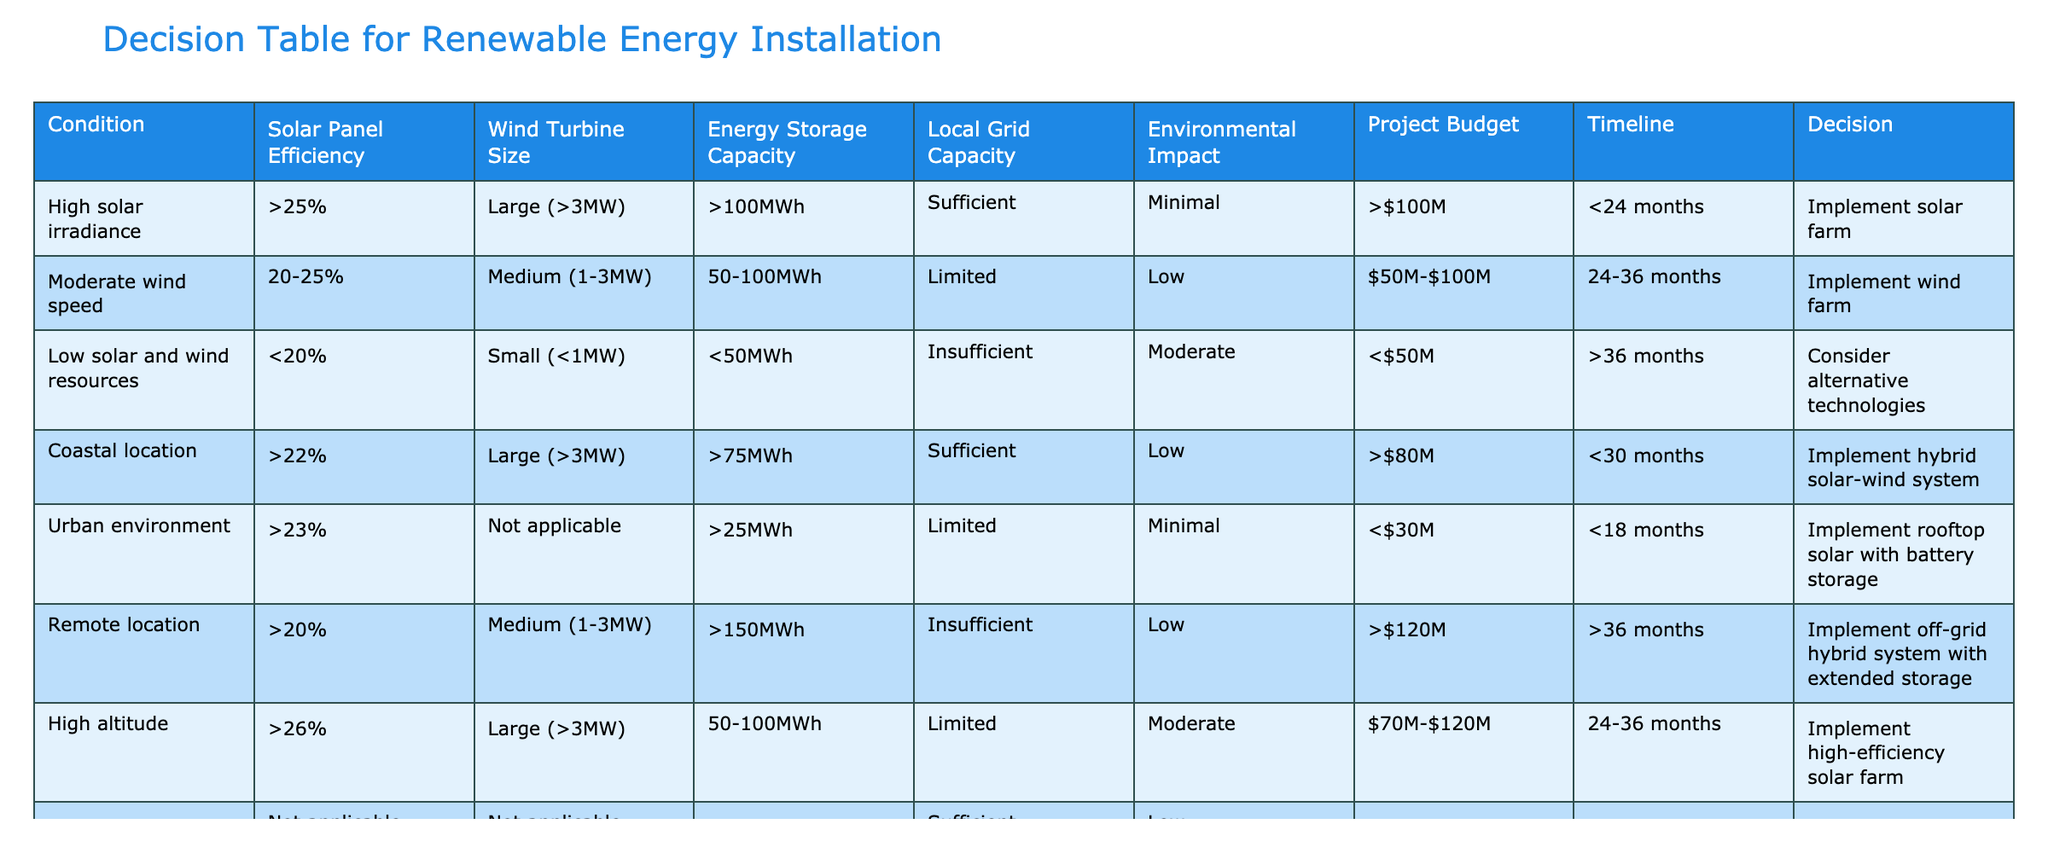What is the decision for a project with high solar irradiance and a project budget of over 100 million dollars? The table indicates that high solar irradiance (>25%) and a project budget over 100M leads to implementing a solar farm. Therefore, we identify the relevant row and check the decision associated with those conditions.
Answer: Implement solar farm Which project has the longest timeline according to the table? By examining the "Timeline" column, we see the longest duration listed is ">48 months," which corresponds to the geothermal power plant project. Thus, we select this specific entry to answer the question.
Answer: Implement geothermal power plant Is it feasible to implement an agrivoltaic system in an area with agricultural land and solar panel efficiency greater than 22%? The table confirms that an agrivoltaic system can be implemented under these conditions. Therefore, the answer is yes.
Answer: Yes What percentage of energy storage capacity is required for a wind farm project with moderate wind speed? The energy storage capacity for a project related to moderate wind speed (20-25%) is specified as 50-100MWh. Therefore, we clarify that this range of storage capacity is necessary for such a project type.
Answer: 50-100MWh How many projects can be implemented in coastal locations based on the conditions listed in the table? There is one entry for coastal locations with suitable conditions indicating the implementation of a hybrid solar-wind system. Thereby, we find that only one project can be implemented.
Answer: One If a remote location has high solar efficiency, what could be the possible decision regarding the project's design? In the remote location scenario, the conditions specify that the efficiency must be greater than 20%, leading to the close result of implementing an off-grid hybrid system with extended storage. This involves confirming the conditions first before identifying the result.
Answer: Implement off-grid hybrid system with extended storage What is the average project budget for the projects listed that implement solar farms? The projects implementing solar farms are as follows: one with a budget over 100M, one in an agricultural area under budget of 40M, and the high-altitude project with a budget of 70-120M. To calculate the average, we consider their mean value, which gives an average of (~120+40+95)/3 = ~85M approximately.
Answer: Approximately 85M Is there a project with minimal environmental impact that would take less than 24 months? Yes, the project for rooftop solar with battery storage fits this criterion, confirming that it has minimal environmental impact and fits the timeline requirement.
Answer: Yes How does the energy storage capacity for a tidal energy system compare to that of a wind farm project? The tidal energy system requires >100MWh of energy storage, while the wind farm requires 50-100MWh. Comparing these, the tidal energy system generally has a higher capacity requirement than the wind farm. Thus, we define this comparison accurately.
Answer: Tidal energy requires more ( >100MWh) 